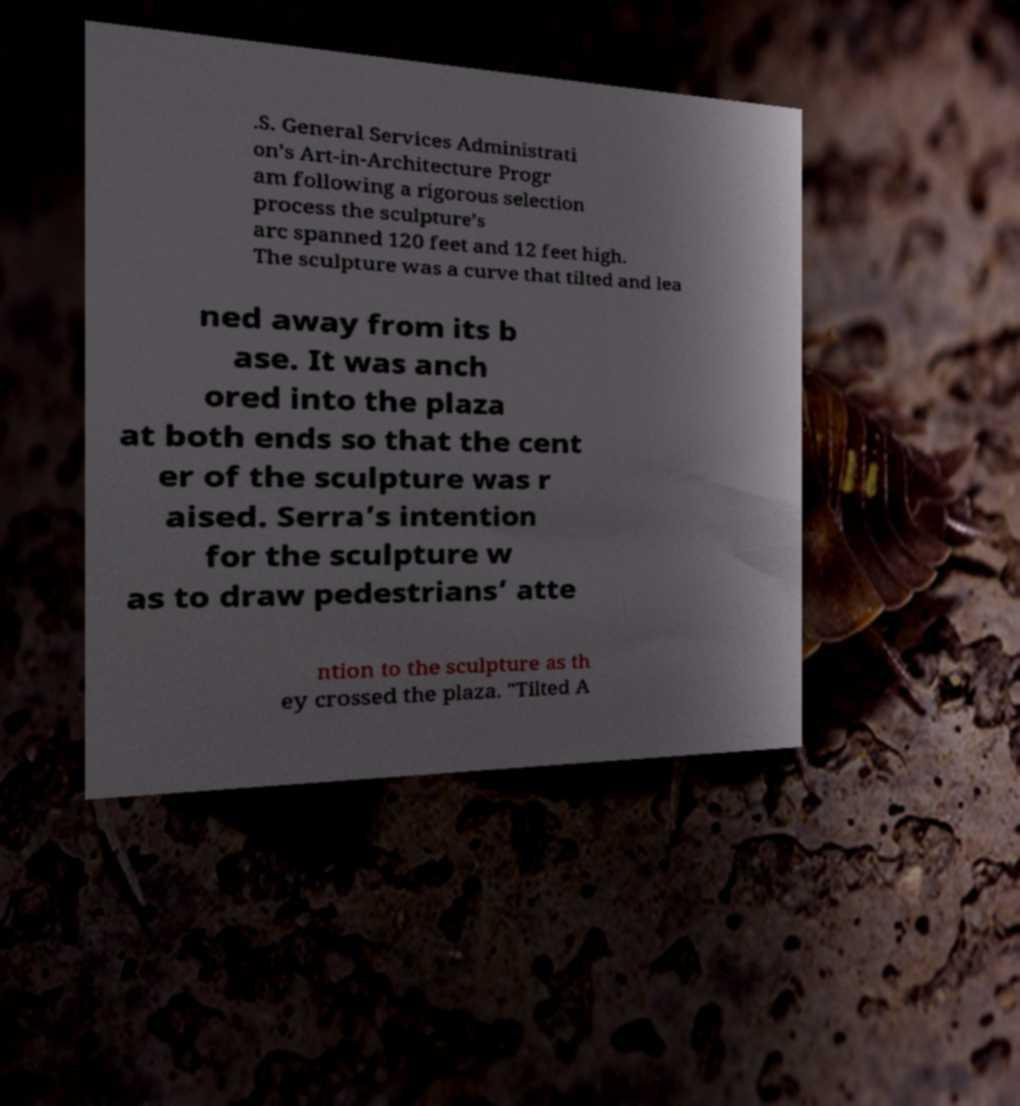Can you accurately transcribe the text from the provided image for me? .S. General Services Administrati on’s Art-in-Architecture Progr am following a rigorous selection process the sculpture’s arc spanned 120 feet and 12 feet high. The sculpture was a curve that tilted and lea ned away from its b ase. It was anch ored into the plaza at both ends so that the cent er of the sculpture was r aised. Serra’s intention for the sculpture w as to draw pedestrians’ atte ntion to the sculpture as th ey crossed the plaza. "Tilted A 